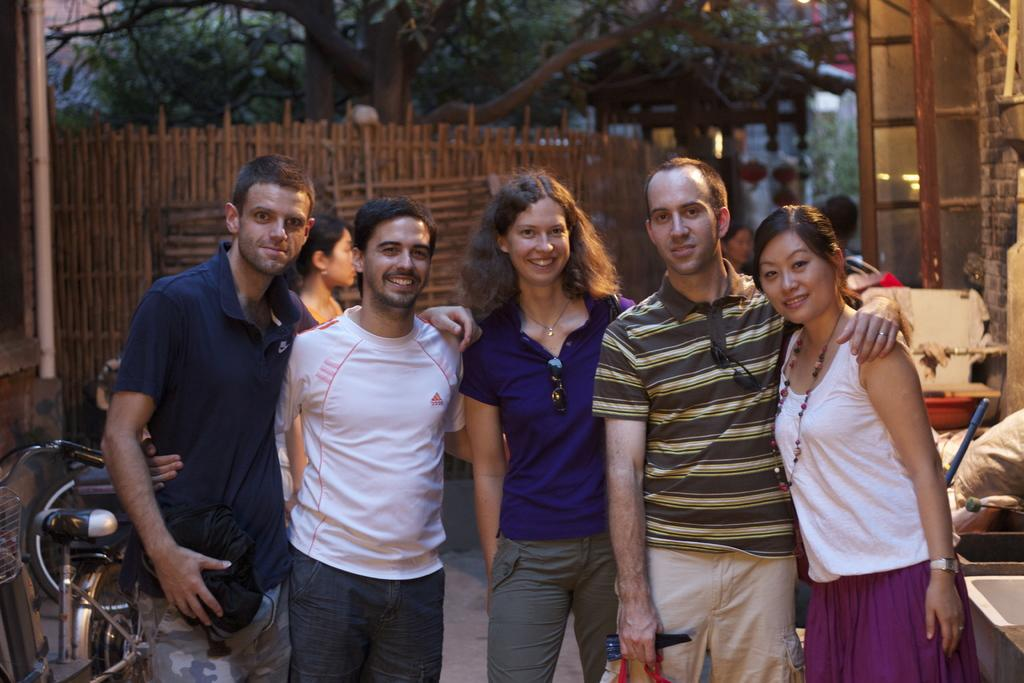What can be seen in the image involving transportation? There is a bicycle in the image. What type of structure is present in the image? There is a wooden fence in the image. What is the purpose of the pipelines visible in the image? The purpose of the pipelines is not specified in the image, but they are likely for transporting liquids or gases. What type of vegetation is present in the image? There are trees in the image. What type of zephyr can be seen blowing through the trees in the image? There is no mention of a zephyr or any wind in the image; it only shows people, a bicycle, a wooden fence, pipelines, and trees. How does the throat of the person standing in the image appear? There is no information about the appearance of anyone's throat in the image. 